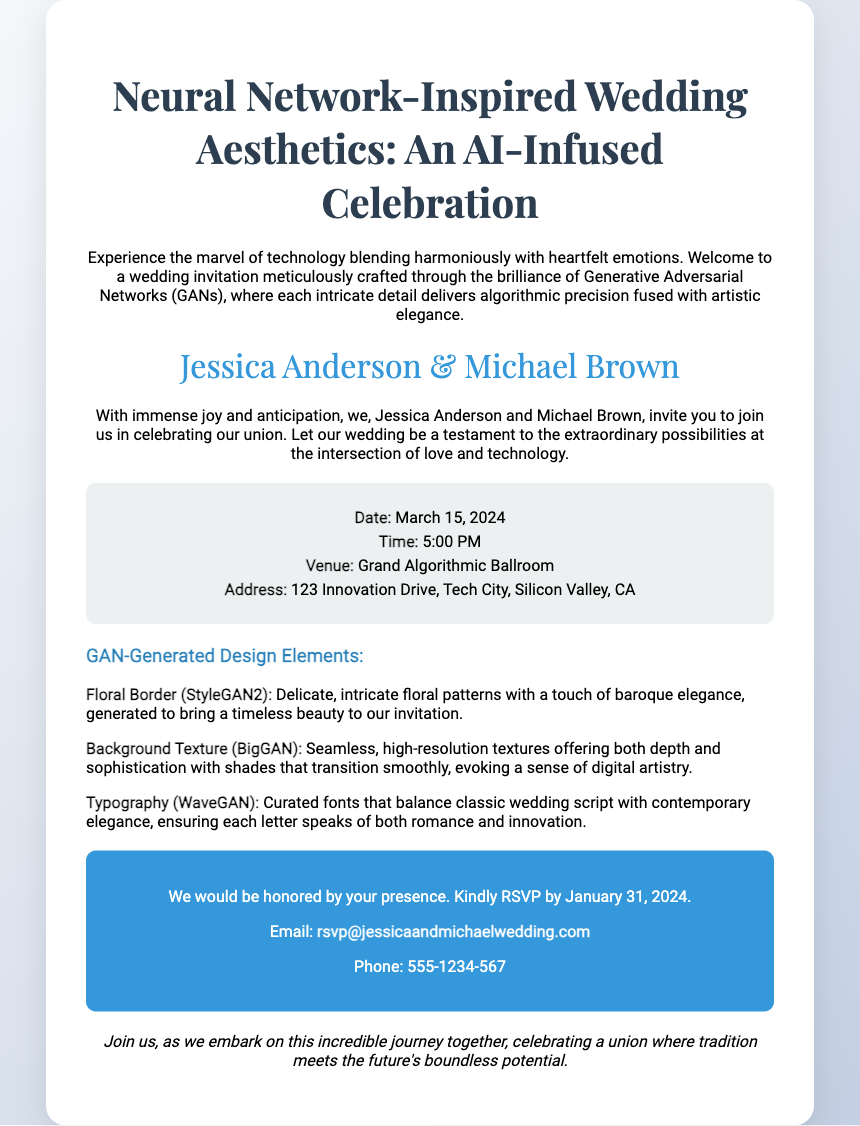What are the names of the couple? The names of the couple, as indicated in the invitation, are Jessica Anderson and Michael Brown.
Answer: Jessica Anderson & Michael Brown What is the date of the wedding? The date is specified in the invitation as March 15, 2024.
Answer: March 15, 2024 Where is the wedding venue located? The venue location is described in the invitation as Grand Algorithmic Ballroom at 123 Innovation Drive, Tech City, Silicon Valley, CA.
Answer: Grand Algorithmic Ballroom What is the RSVP deadline? The RSVP deadline is stated in the invitation as January 31, 2024.
Answer: January 31, 2024 What type of artistic style is used for the floral border? The floral border is generated using StyleGAN2, which is mentioned in the design details section.
Answer: StyleGAN2 How does the background texture of the invitation contribute to its design? The background texture is created using BigGAN to provide depth and sophistication with a digital artistry feel.
Answer: BigGAN What is the purpose of the invitation's design? The design aims to blend technology with heartfelt emotions, showcasing the integration of love and technology.
Answer: AI-Infused Celebration What should guests do to confirm their attendance? Guests are asked to kindly RSVP to indicate their presence at the wedding.
Answer: Kindly RSVP What represents the union of the couple in the invitation? The couple's names and the invitation's thematic elements reflect their union and celebration.
Answer: Union 